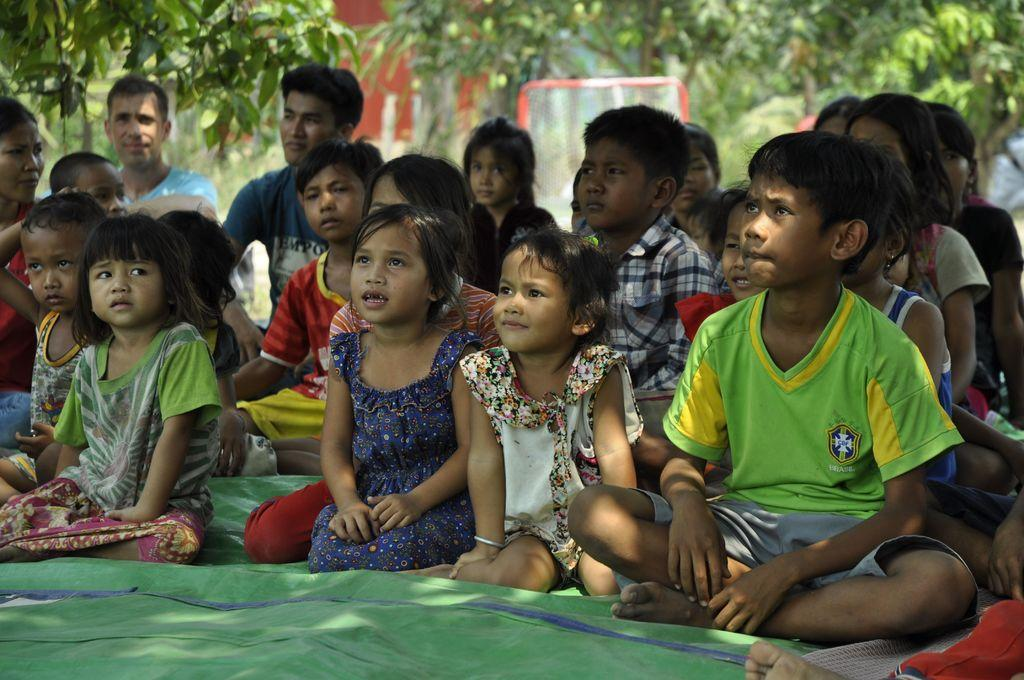Who is present in the image? There are kids and men in the image. What are they doing in the image? They are sitting on a green cloth. What can be seen in the background of the image? There are trees and a net in the background of the image. What type of glove is being used by the kids in the image? There is no glove present in the image. Why are the men in the image crying? There is no indication in the image that the men are crying. 